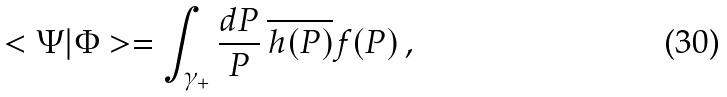Convert formula to latex. <formula><loc_0><loc_0><loc_500><loc_500>< \Psi | \Phi > = \int _ { \gamma _ { + } } \frac { d P } { P } \, \overline { h ( P ) } f ( P ) \, ,</formula> 